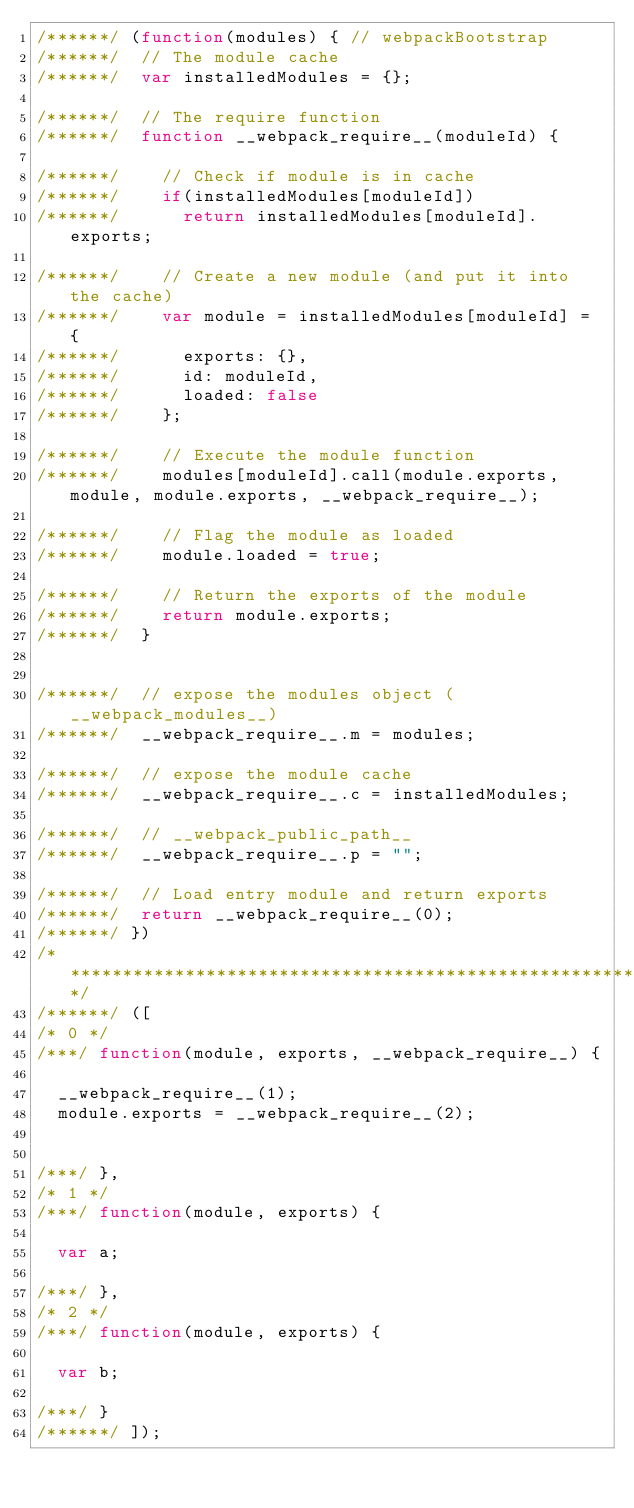<code> <loc_0><loc_0><loc_500><loc_500><_JavaScript_>/******/ (function(modules) { // webpackBootstrap
/******/ 	// The module cache
/******/ 	var installedModules = {};

/******/ 	// The require function
/******/ 	function __webpack_require__(moduleId) {

/******/ 		// Check if module is in cache
/******/ 		if(installedModules[moduleId])
/******/ 			return installedModules[moduleId].exports;

/******/ 		// Create a new module (and put it into the cache)
/******/ 		var module = installedModules[moduleId] = {
/******/ 			exports: {},
/******/ 			id: moduleId,
/******/ 			loaded: false
/******/ 		};

/******/ 		// Execute the module function
/******/ 		modules[moduleId].call(module.exports, module, module.exports, __webpack_require__);

/******/ 		// Flag the module as loaded
/******/ 		module.loaded = true;

/******/ 		// Return the exports of the module
/******/ 		return module.exports;
/******/ 	}


/******/ 	// expose the modules object (__webpack_modules__)
/******/ 	__webpack_require__.m = modules;

/******/ 	// expose the module cache
/******/ 	__webpack_require__.c = installedModules;

/******/ 	// __webpack_public_path__
/******/ 	__webpack_require__.p = "";

/******/ 	// Load entry module and return exports
/******/ 	return __webpack_require__(0);
/******/ })
/************************************************************************/
/******/ ([
/* 0 */
/***/ function(module, exports, __webpack_require__) {

	__webpack_require__(1);
	module.exports = __webpack_require__(2);


/***/ },
/* 1 */
/***/ function(module, exports) {

	var a;

/***/ },
/* 2 */
/***/ function(module, exports) {

	var b;

/***/ }
/******/ ]);</code> 